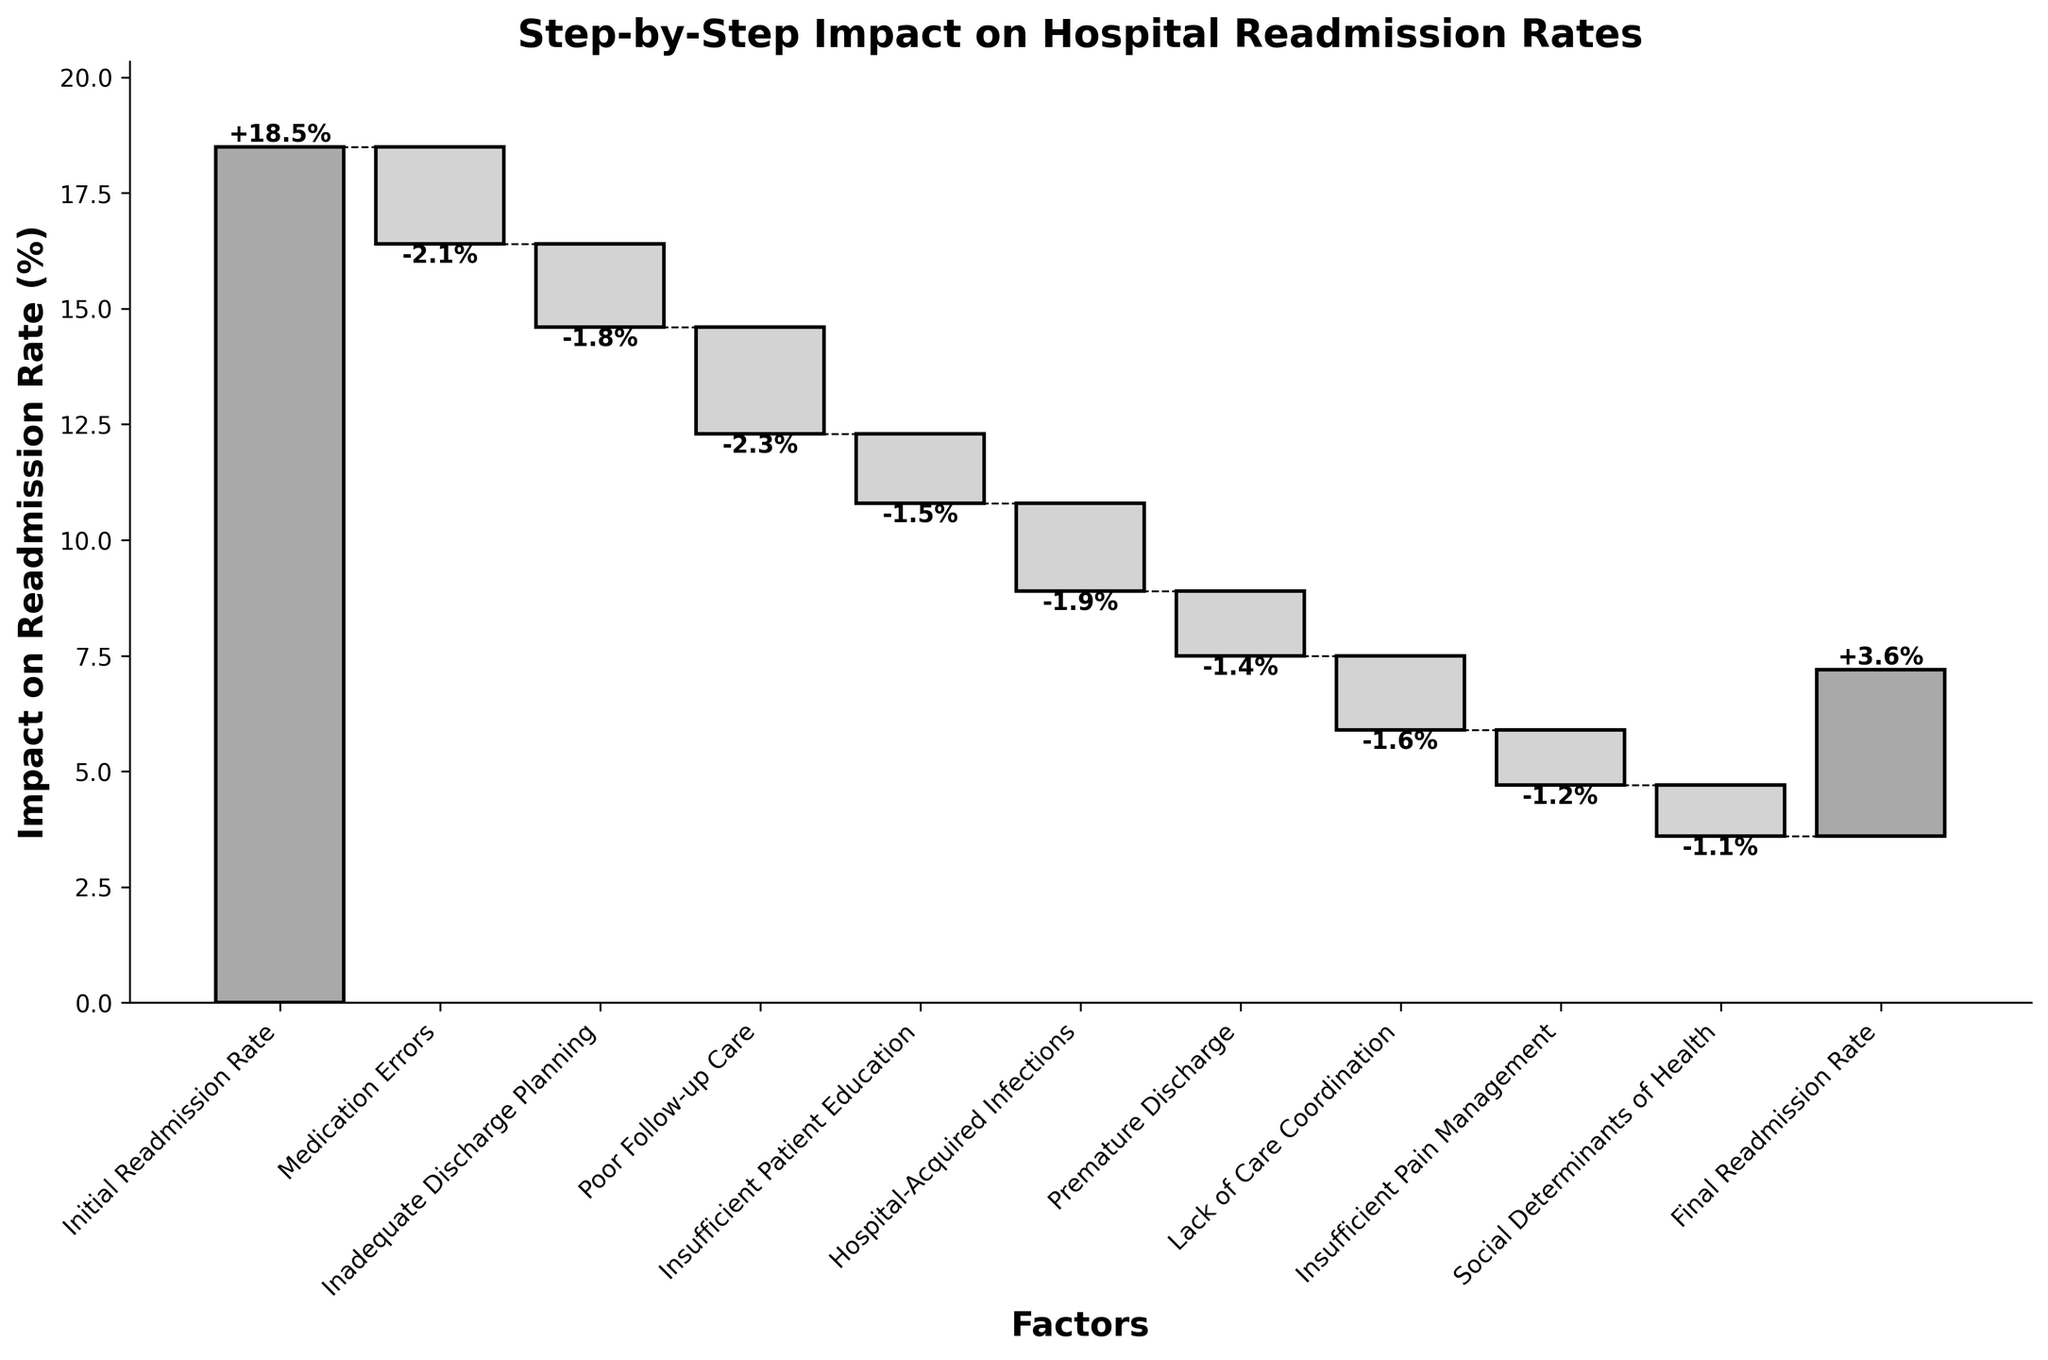What is the initial readmission rate mentioned in the figure? The initial readmission rate is given as the starting point in the waterfall chart. It is mentioned at the beginning of the chart.
Answer: 18.5% How much does medication errors reduce the readmission rate by? The impact of medication errors on the readmission rate is shown as a negative value in the plot. The bar labeled "Medication Errors" indicates this impact.
Answer: -2.1% Which factor has the largest negative impact on the readmission rate? By examining the figure, the factor with the longest bar pointing downwards has the largest negative impact. "Poor Follow-up Care" has an impact of -2.3%, which is the largest.
Answer: Poor Follow-up Care What is the final readmission rate after accounting for all factors? The cumulative impact of all factors gives the final readmission rate, which is shown as the last bar in the waterfall chart.
Answer: 3.6% How many factors contribute to reducing the readmission rate? (excluding initial and final rates) Count the number of bars besides the initial and final readmission rates. Each bar represents a factor.
Answer: 8 What is the total impact of inadequate discharge planning and premature discharge combined? Add the individual impacts of "Inadequate Discharge Planning" (-1.8) and "Premature Discharge" (-1.4). The sum is -3.2%.
Answer: -3.2% Which factor has a smaller impact: insufficient patient education or hospital-acquired infections? Compare the impacts of both factors: "Insufficient Patient Education" (-1.5) and "Hospital-Acquired Infections" (-1.9).
Answer: Insufficient Patient Education What is the cumulative reduction in readmission rate before accounting for social determinants of health? Sum up all the impacts of the factors before "Social Determinants of Health": -2.1 - 1.8 - 2.3 - 1.5 -1.9 - 1.4 - 1.6 - 1.2. The result is -13.8%.
Answer: -13.8% How does the impact of insufficient pain management compare to that of lack of care coordination? Compare their impacts: "Insufficient Pain Management" has -1.2%, which is less negative than "Lack of Care Coordination" with -1.6%.
Answer: Less negative 